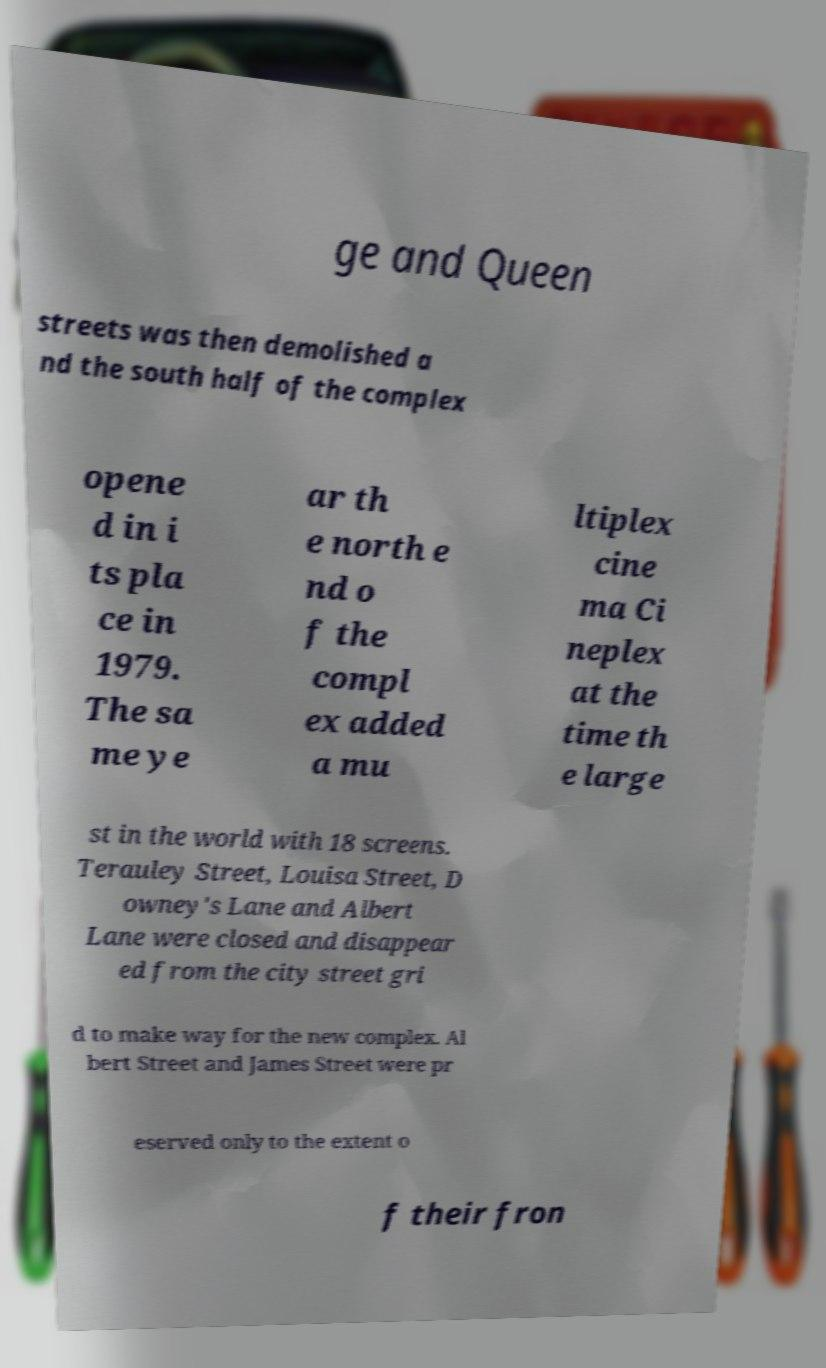There's text embedded in this image that I need extracted. Can you transcribe it verbatim? ge and Queen streets was then demolished a nd the south half of the complex opene d in i ts pla ce in 1979. The sa me ye ar th e north e nd o f the compl ex added a mu ltiplex cine ma Ci neplex at the time th e large st in the world with 18 screens. Terauley Street, Louisa Street, D owney's Lane and Albert Lane were closed and disappear ed from the city street gri d to make way for the new complex. Al bert Street and James Street were pr eserved only to the extent o f their fron 